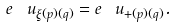Convert formula to latex. <formula><loc_0><loc_0><loc_500><loc_500>e ^ { \ } u _ { \xi ( p ) ( q ) } = e ^ { \ } u _ { + ( p ) ( q ) } .</formula> 